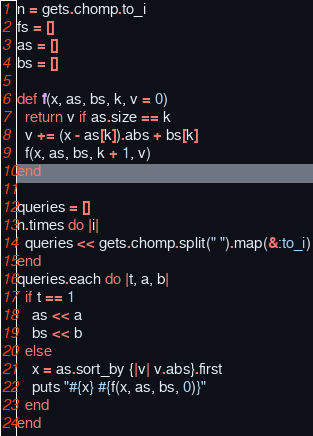<code> <loc_0><loc_0><loc_500><loc_500><_Ruby_>n = gets.chomp.to_i
fs = []
as = []
bs = []

def f(x, as, bs, k, v = 0)
  return v if as.size == k
  v += (x - as[k]).abs + bs[k]
  f(x, as, bs, k + 1, v)
end

queries = []
n.times do |i|
  queries << gets.chomp.split(" ").map(&:to_i)
end
queries.each do |t, a, b|
  if t == 1
    as << a
    bs << b
  else
    x = as.sort_by {|v| v.abs}.first
    puts "#{x} #{f(x, as, bs, 0)}"
  end
end
</code> 